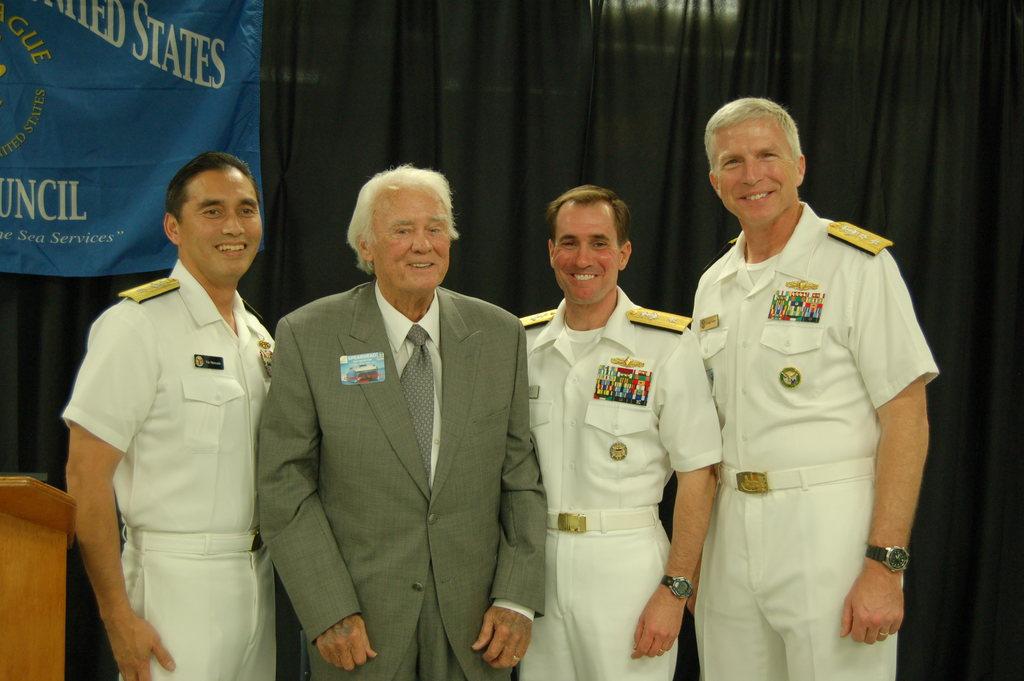What color is the mans uniform?
Give a very brief answer. White. 